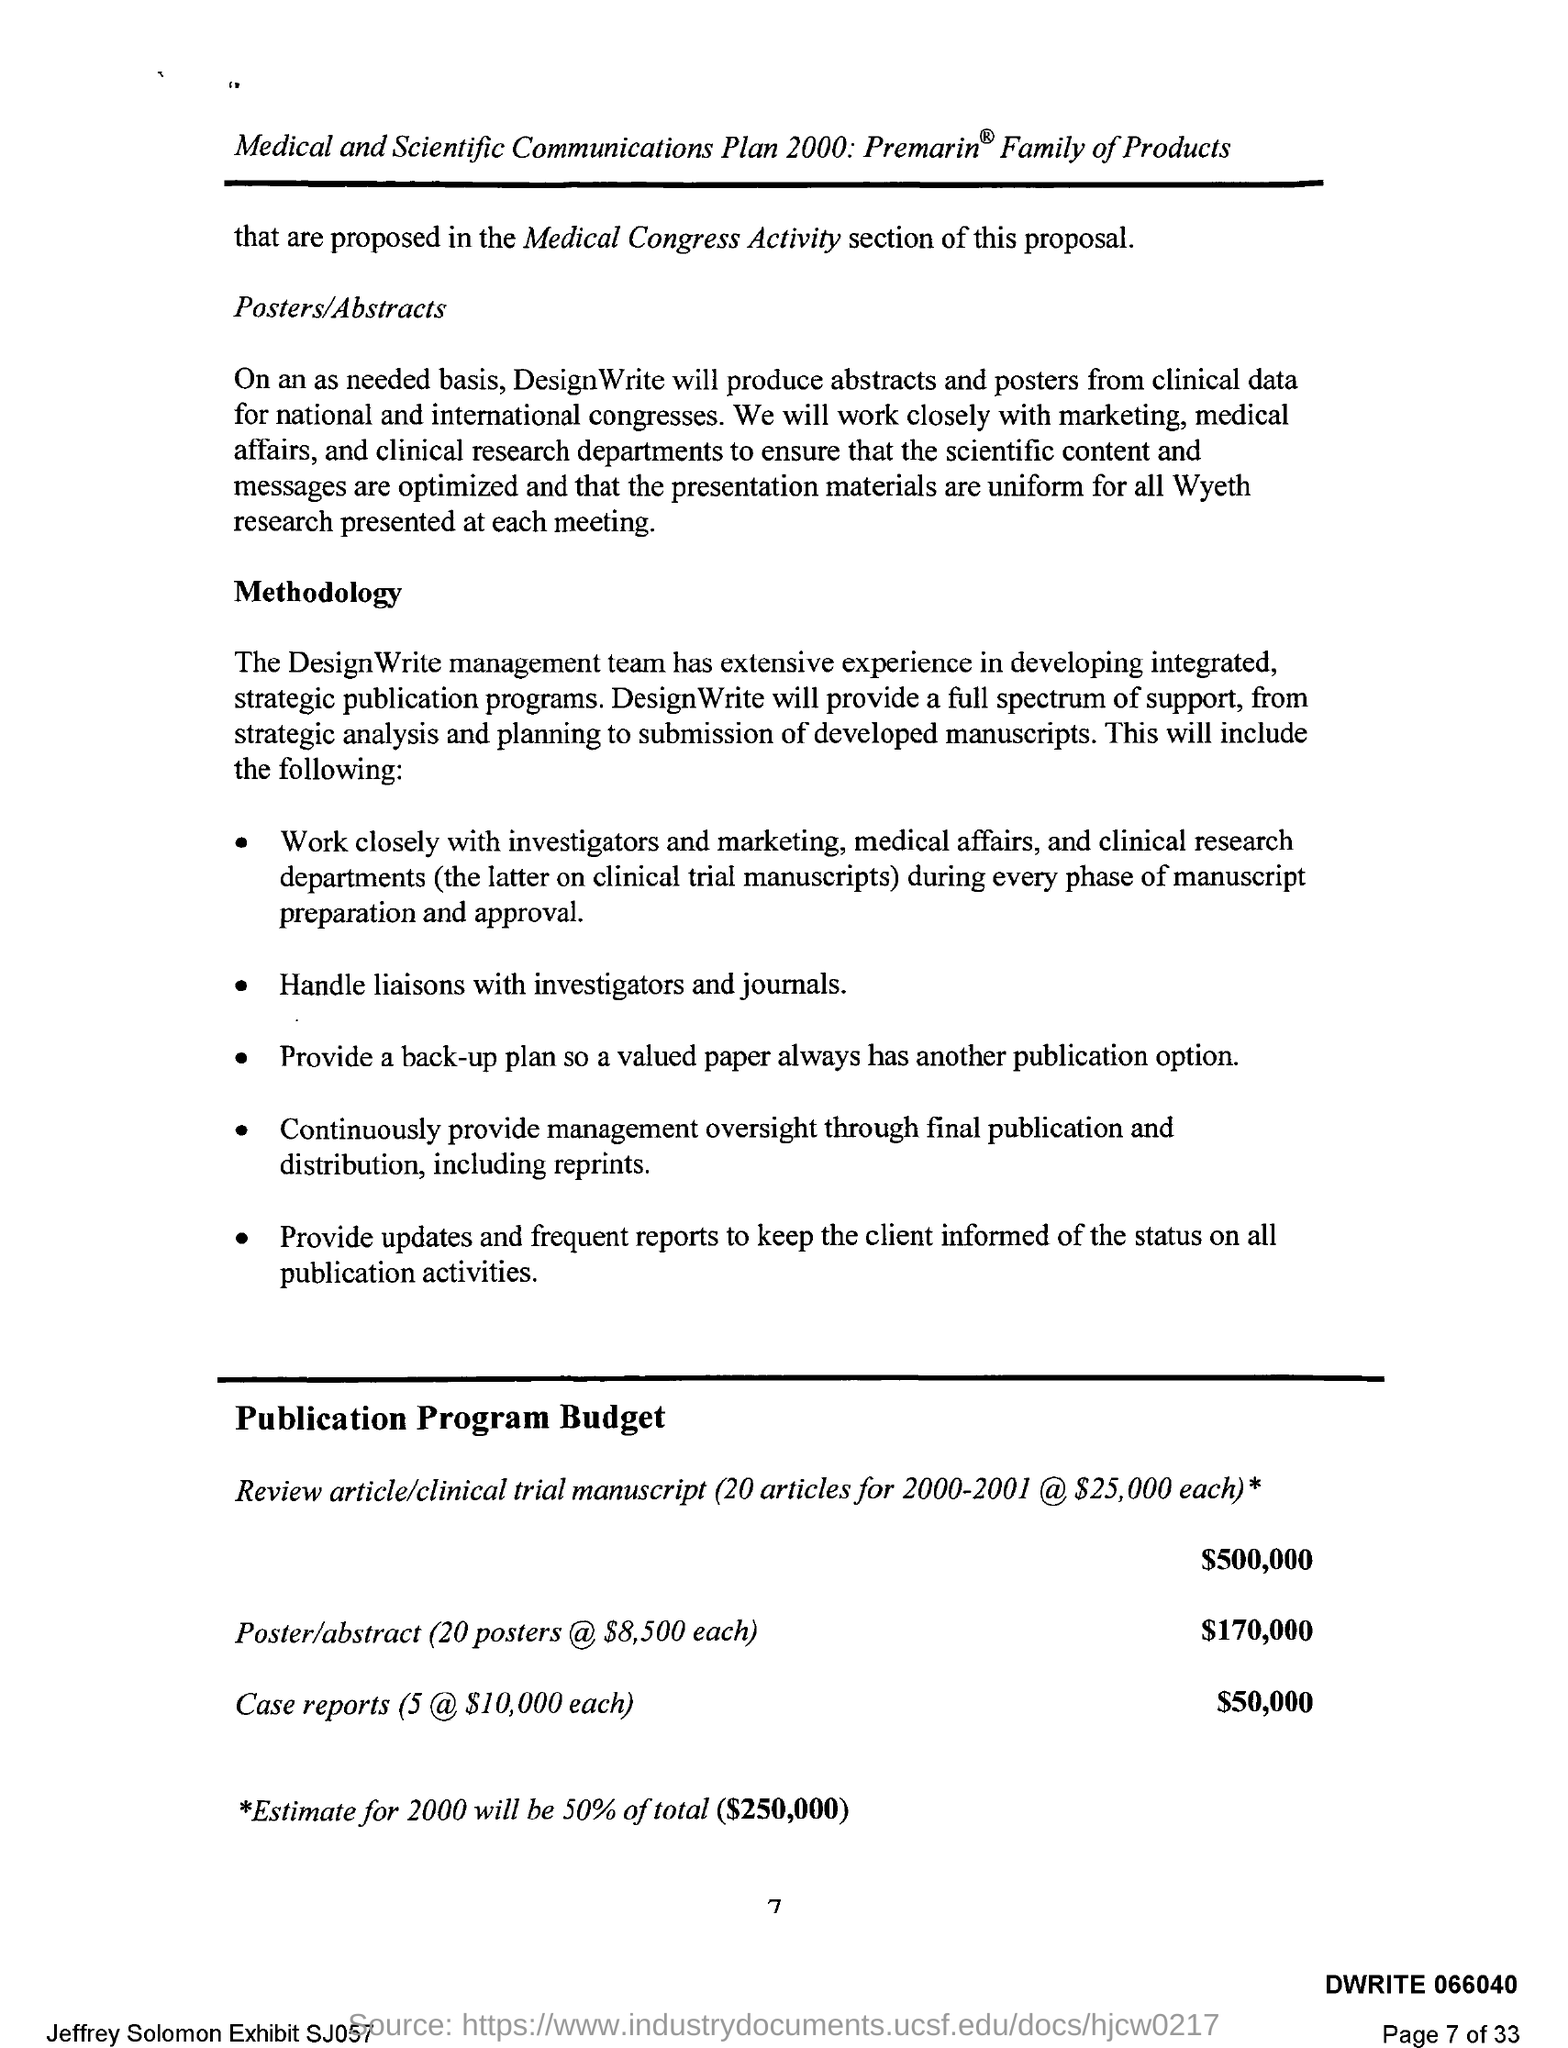What is the Page Number?
Your response must be concise. 7. What is the budget for the poster/abstract?
Provide a short and direct response. $170,000. What is the budget for case reports?
Ensure brevity in your answer.  $50,000. What is the budget for the review article/clinical trial manuscript?
Give a very brief answer. $500,000. 